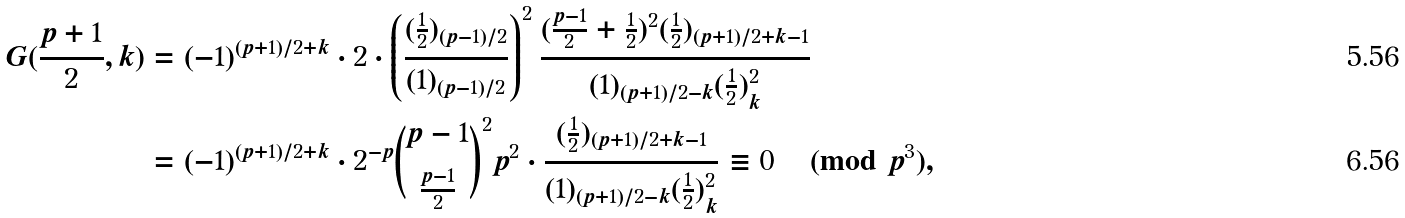<formula> <loc_0><loc_0><loc_500><loc_500>G ( \frac { p + 1 } 2 , k ) & = ( - 1 ) ^ { ( p + 1 ) / 2 + k } \cdot 2 \cdot \left ( \frac { ( \frac { 1 } { 2 } ) _ { ( p - 1 ) / 2 } } { ( 1 ) _ { ( p - 1 ) / 2 } } \right ) ^ { 2 } \frac { ( \frac { p - 1 } 2 + \frac { 1 } { 2 } ) ^ { 2 } ( \frac { 1 } { 2 } ) _ { ( p + 1 ) / 2 + k - 1 } } { ( 1 ) _ { ( p + 1 ) / 2 - k } ( \frac { 1 } { 2 } ) _ { k } ^ { 2 } } \\ & = ( - 1 ) ^ { ( p + 1 ) / 2 + k } \cdot 2 ^ { - p } { \binom { p - 1 } { \frac { p - 1 } 2 } } ^ { 2 } p ^ { 2 } \cdot \frac { ( \frac { 1 } { 2 } ) _ { ( p + 1 ) / 2 + k - 1 } } { ( 1 ) _ { ( p + 1 ) / 2 - k } ( \frac { 1 } { 2 } ) _ { k } ^ { 2 } } \equiv 0 \pmod { p ^ { 3 } } ,</formula> 